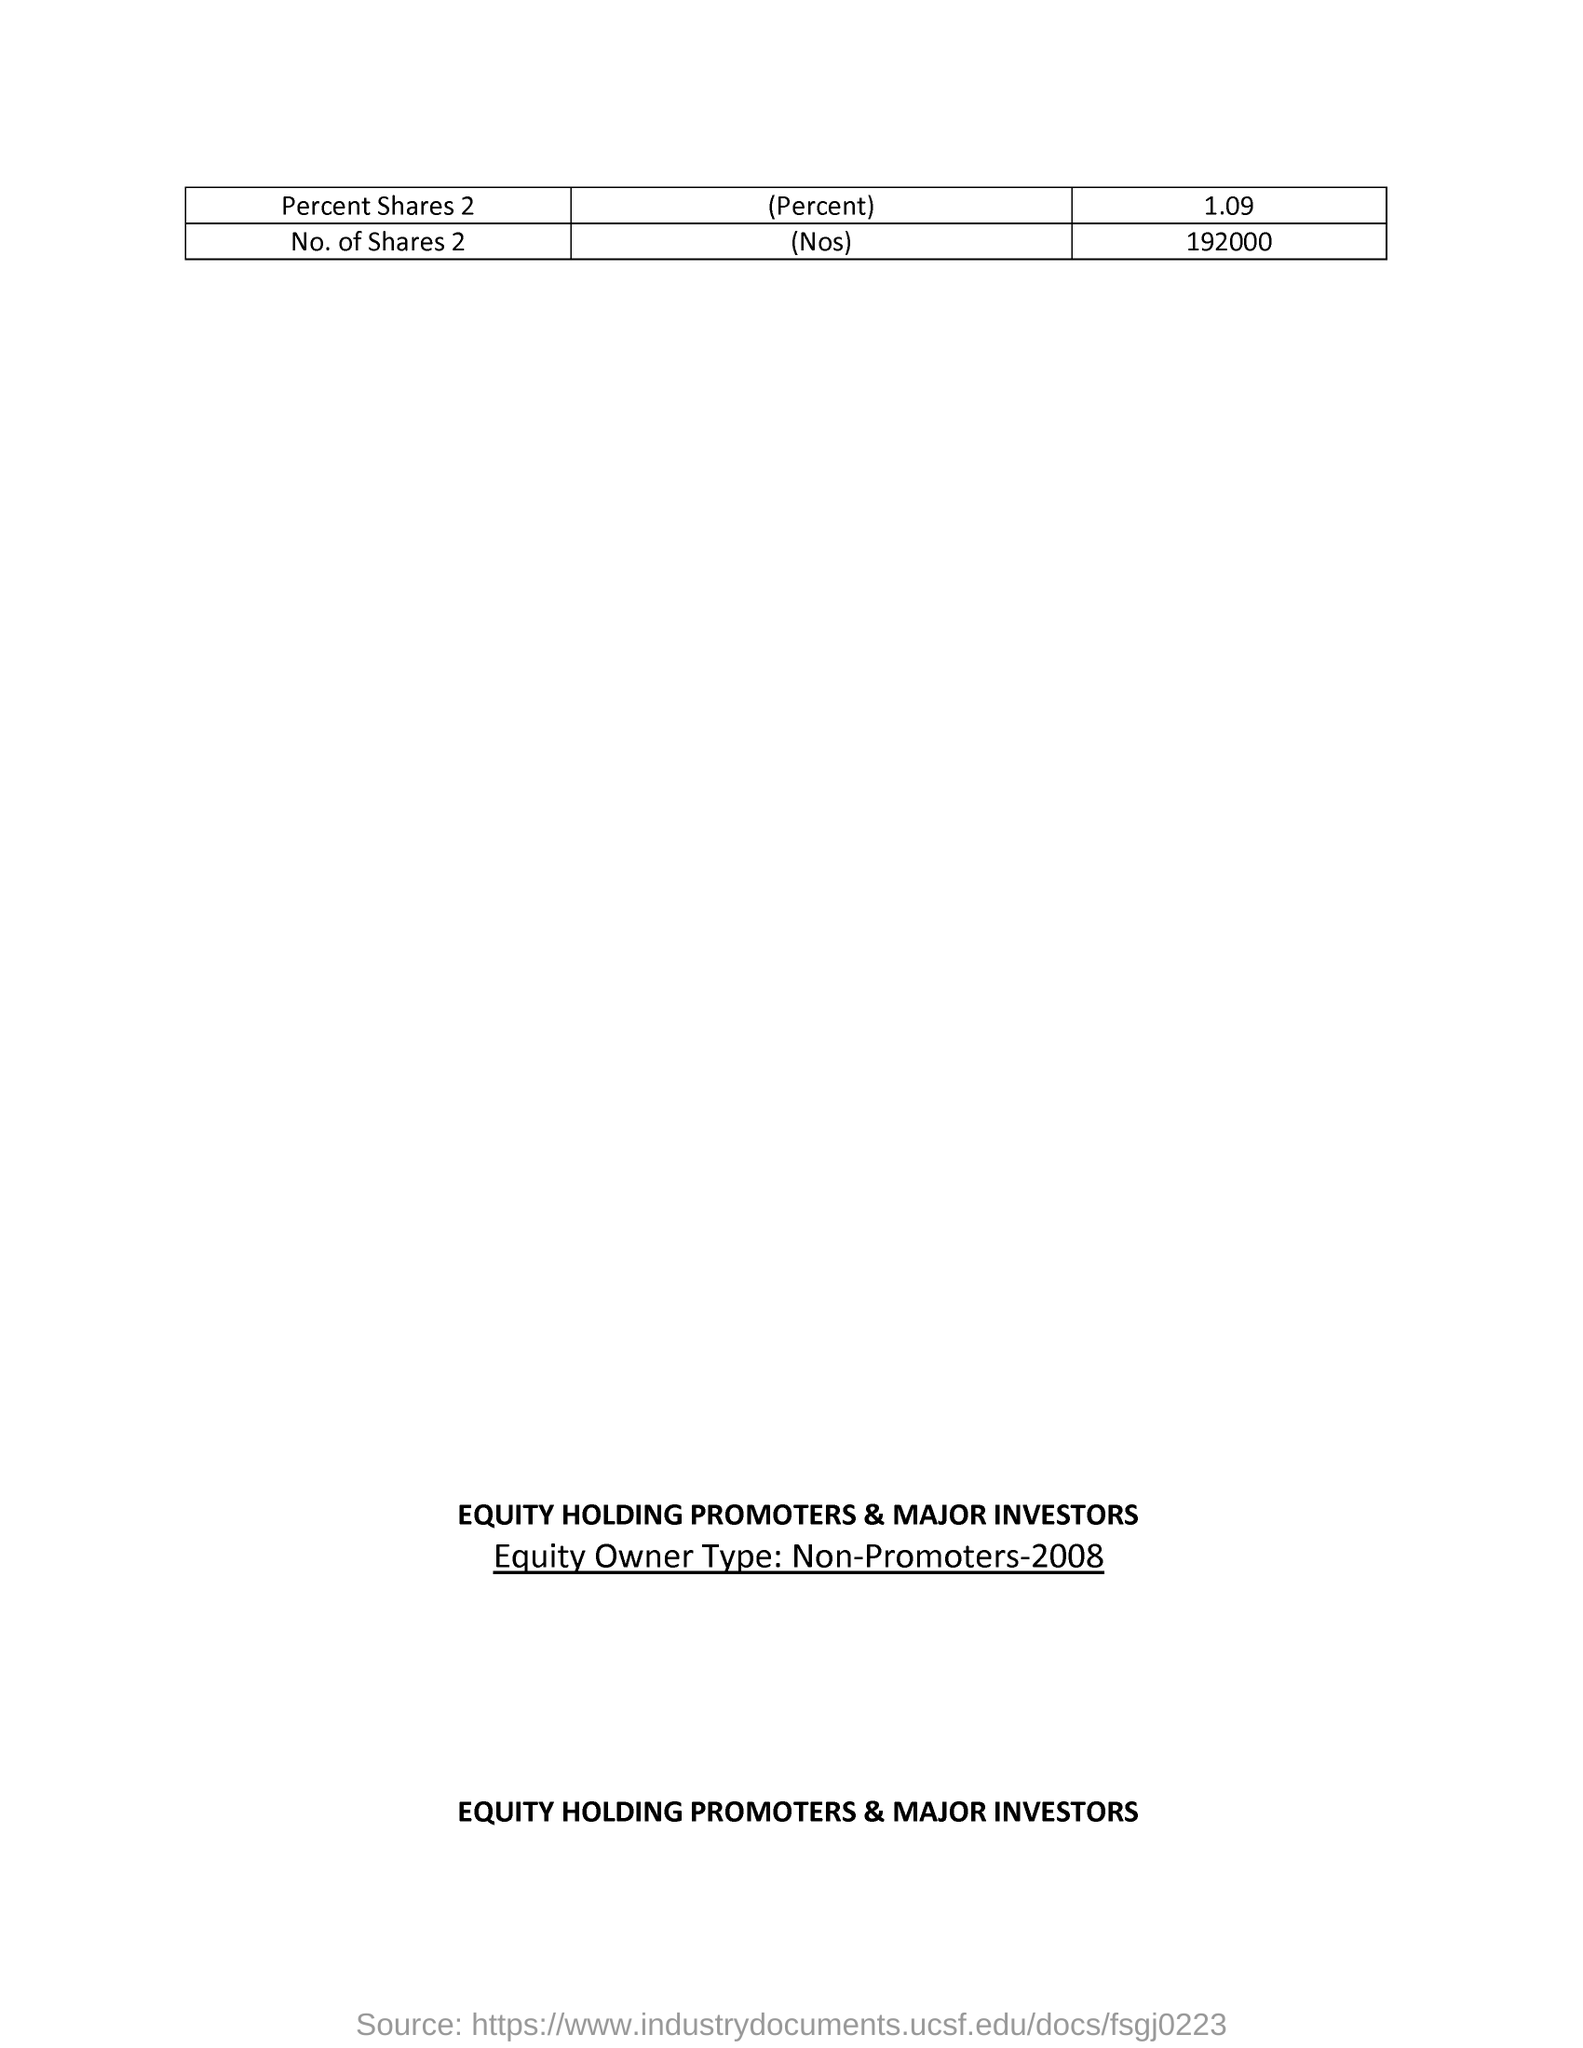Give some essential details in this illustration. The equity owner type refers to non-promoters from 2008. 